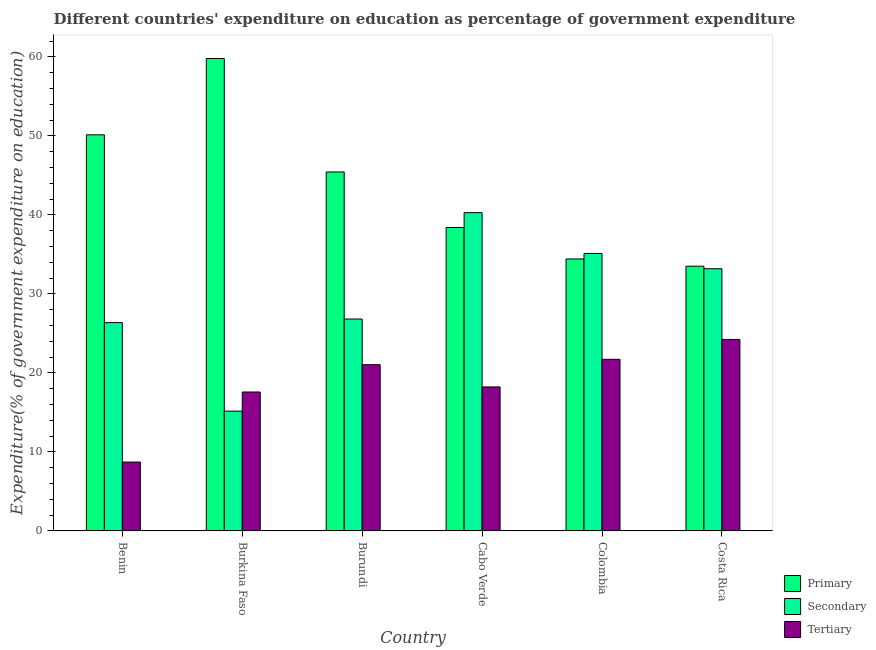How many groups of bars are there?
Keep it short and to the point. 6. Are the number of bars per tick equal to the number of legend labels?
Your answer should be compact. Yes. Are the number of bars on each tick of the X-axis equal?
Ensure brevity in your answer.  Yes. What is the label of the 6th group of bars from the left?
Offer a very short reply. Costa Rica. What is the expenditure on primary education in Burundi?
Your answer should be compact. 45.43. Across all countries, what is the maximum expenditure on primary education?
Offer a terse response. 59.79. Across all countries, what is the minimum expenditure on primary education?
Make the answer very short. 33.5. In which country was the expenditure on secondary education maximum?
Keep it short and to the point. Cabo Verde. In which country was the expenditure on secondary education minimum?
Offer a very short reply. Burkina Faso. What is the total expenditure on tertiary education in the graph?
Your response must be concise. 111.51. What is the difference between the expenditure on tertiary education in Cabo Verde and that in Colombia?
Give a very brief answer. -3.49. What is the difference between the expenditure on tertiary education in Benin and the expenditure on primary education in Cabo Verde?
Keep it short and to the point. -29.68. What is the average expenditure on secondary education per country?
Offer a very short reply. 29.49. What is the difference between the expenditure on secondary education and expenditure on primary education in Colombia?
Provide a short and direct response. 0.69. In how many countries, is the expenditure on primary education greater than 14 %?
Your answer should be very brief. 6. What is the ratio of the expenditure on secondary education in Burundi to that in Costa Rica?
Your response must be concise. 0.81. What is the difference between the highest and the second highest expenditure on tertiary education?
Offer a terse response. 2.52. What is the difference between the highest and the lowest expenditure on secondary education?
Ensure brevity in your answer.  25.12. Is the sum of the expenditure on primary education in Benin and Burundi greater than the maximum expenditure on tertiary education across all countries?
Keep it short and to the point. Yes. What does the 3rd bar from the left in Costa Rica represents?
Provide a short and direct response. Tertiary. What does the 3rd bar from the right in Burkina Faso represents?
Ensure brevity in your answer.  Primary. How many bars are there?
Provide a succinct answer. 18. What is the difference between two consecutive major ticks on the Y-axis?
Your response must be concise. 10. Are the values on the major ticks of Y-axis written in scientific E-notation?
Give a very brief answer. No. Does the graph contain grids?
Offer a terse response. No. Where does the legend appear in the graph?
Give a very brief answer. Bottom right. How many legend labels are there?
Provide a succinct answer. 3. How are the legend labels stacked?
Offer a very short reply. Vertical. What is the title of the graph?
Offer a terse response. Different countries' expenditure on education as percentage of government expenditure. What is the label or title of the Y-axis?
Your answer should be compact. Expenditure(% of government expenditure on education). What is the Expenditure(% of government expenditure on education) of Primary in Benin?
Keep it short and to the point. 50.13. What is the Expenditure(% of government expenditure on education) in Secondary in Benin?
Your response must be concise. 26.36. What is the Expenditure(% of government expenditure on education) in Tertiary in Benin?
Ensure brevity in your answer.  8.72. What is the Expenditure(% of government expenditure on education) in Primary in Burkina Faso?
Provide a short and direct response. 59.79. What is the Expenditure(% of government expenditure on education) of Secondary in Burkina Faso?
Your answer should be compact. 15.16. What is the Expenditure(% of government expenditure on education) of Tertiary in Burkina Faso?
Your answer should be compact. 17.58. What is the Expenditure(% of government expenditure on education) of Primary in Burundi?
Offer a terse response. 45.43. What is the Expenditure(% of government expenditure on education) of Secondary in Burundi?
Provide a short and direct response. 26.82. What is the Expenditure(% of government expenditure on education) of Tertiary in Burundi?
Make the answer very short. 21.04. What is the Expenditure(% of government expenditure on education) in Primary in Cabo Verde?
Your answer should be compact. 38.4. What is the Expenditure(% of government expenditure on education) of Secondary in Cabo Verde?
Keep it short and to the point. 40.28. What is the Expenditure(% of government expenditure on education) in Tertiary in Cabo Verde?
Your response must be concise. 18.23. What is the Expenditure(% of government expenditure on education) in Primary in Colombia?
Your answer should be compact. 34.42. What is the Expenditure(% of government expenditure on education) of Secondary in Colombia?
Ensure brevity in your answer.  35.11. What is the Expenditure(% of government expenditure on education) of Tertiary in Colombia?
Provide a succinct answer. 21.72. What is the Expenditure(% of government expenditure on education) in Primary in Costa Rica?
Ensure brevity in your answer.  33.5. What is the Expenditure(% of government expenditure on education) of Secondary in Costa Rica?
Give a very brief answer. 33.18. What is the Expenditure(% of government expenditure on education) of Tertiary in Costa Rica?
Your response must be concise. 24.23. Across all countries, what is the maximum Expenditure(% of government expenditure on education) in Primary?
Provide a short and direct response. 59.79. Across all countries, what is the maximum Expenditure(% of government expenditure on education) of Secondary?
Ensure brevity in your answer.  40.28. Across all countries, what is the maximum Expenditure(% of government expenditure on education) in Tertiary?
Your response must be concise. 24.23. Across all countries, what is the minimum Expenditure(% of government expenditure on education) in Primary?
Make the answer very short. 33.5. Across all countries, what is the minimum Expenditure(% of government expenditure on education) of Secondary?
Provide a short and direct response. 15.16. Across all countries, what is the minimum Expenditure(% of government expenditure on education) of Tertiary?
Offer a terse response. 8.72. What is the total Expenditure(% of government expenditure on education) in Primary in the graph?
Ensure brevity in your answer.  261.67. What is the total Expenditure(% of government expenditure on education) of Secondary in the graph?
Offer a very short reply. 176.92. What is the total Expenditure(% of government expenditure on education) of Tertiary in the graph?
Offer a terse response. 111.51. What is the difference between the Expenditure(% of government expenditure on education) in Primary in Benin and that in Burkina Faso?
Make the answer very short. -9.66. What is the difference between the Expenditure(% of government expenditure on education) in Secondary in Benin and that in Burkina Faso?
Provide a succinct answer. 11.2. What is the difference between the Expenditure(% of government expenditure on education) of Tertiary in Benin and that in Burkina Faso?
Provide a short and direct response. -8.87. What is the difference between the Expenditure(% of government expenditure on education) in Primary in Benin and that in Burundi?
Keep it short and to the point. 4.7. What is the difference between the Expenditure(% of government expenditure on education) in Secondary in Benin and that in Burundi?
Ensure brevity in your answer.  -0.45. What is the difference between the Expenditure(% of government expenditure on education) in Tertiary in Benin and that in Burundi?
Provide a short and direct response. -12.32. What is the difference between the Expenditure(% of government expenditure on education) of Primary in Benin and that in Cabo Verde?
Provide a short and direct response. 11.73. What is the difference between the Expenditure(% of government expenditure on education) of Secondary in Benin and that in Cabo Verde?
Provide a succinct answer. -13.92. What is the difference between the Expenditure(% of government expenditure on education) of Tertiary in Benin and that in Cabo Verde?
Your answer should be very brief. -9.51. What is the difference between the Expenditure(% of government expenditure on education) in Primary in Benin and that in Colombia?
Provide a short and direct response. 15.71. What is the difference between the Expenditure(% of government expenditure on education) in Secondary in Benin and that in Colombia?
Ensure brevity in your answer.  -8.75. What is the difference between the Expenditure(% of government expenditure on education) in Tertiary in Benin and that in Colombia?
Your answer should be very brief. -13. What is the difference between the Expenditure(% of government expenditure on education) of Primary in Benin and that in Costa Rica?
Provide a short and direct response. 16.63. What is the difference between the Expenditure(% of government expenditure on education) of Secondary in Benin and that in Costa Rica?
Provide a short and direct response. -6.82. What is the difference between the Expenditure(% of government expenditure on education) of Tertiary in Benin and that in Costa Rica?
Keep it short and to the point. -15.52. What is the difference between the Expenditure(% of government expenditure on education) of Primary in Burkina Faso and that in Burundi?
Offer a terse response. 14.36. What is the difference between the Expenditure(% of government expenditure on education) of Secondary in Burkina Faso and that in Burundi?
Give a very brief answer. -11.66. What is the difference between the Expenditure(% of government expenditure on education) in Tertiary in Burkina Faso and that in Burundi?
Your response must be concise. -3.45. What is the difference between the Expenditure(% of government expenditure on education) of Primary in Burkina Faso and that in Cabo Verde?
Your response must be concise. 21.39. What is the difference between the Expenditure(% of government expenditure on education) in Secondary in Burkina Faso and that in Cabo Verde?
Your response must be concise. -25.12. What is the difference between the Expenditure(% of government expenditure on education) in Tertiary in Burkina Faso and that in Cabo Verde?
Ensure brevity in your answer.  -0.64. What is the difference between the Expenditure(% of government expenditure on education) in Primary in Burkina Faso and that in Colombia?
Provide a succinct answer. 25.37. What is the difference between the Expenditure(% of government expenditure on education) in Secondary in Burkina Faso and that in Colombia?
Offer a very short reply. -19.95. What is the difference between the Expenditure(% of government expenditure on education) in Tertiary in Burkina Faso and that in Colombia?
Provide a succinct answer. -4.14. What is the difference between the Expenditure(% of government expenditure on education) in Primary in Burkina Faso and that in Costa Rica?
Keep it short and to the point. 26.29. What is the difference between the Expenditure(% of government expenditure on education) of Secondary in Burkina Faso and that in Costa Rica?
Your response must be concise. -18.02. What is the difference between the Expenditure(% of government expenditure on education) of Tertiary in Burkina Faso and that in Costa Rica?
Give a very brief answer. -6.65. What is the difference between the Expenditure(% of government expenditure on education) of Primary in Burundi and that in Cabo Verde?
Ensure brevity in your answer.  7.03. What is the difference between the Expenditure(% of government expenditure on education) in Secondary in Burundi and that in Cabo Verde?
Offer a terse response. -13.46. What is the difference between the Expenditure(% of government expenditure on education) in Tertiary in Burundi and that in Cabo Verde?
Offer a very short reply. 2.81. What is the difference between the Expenditure(% of government expenditure on education) of Primary in Burundi and that in Colombia?
Give a very brief answer. 11.01. What is the difference between the Expenditure(% of government expenditure on education) of Secondary in Burundi and that in Colombia?
Your answer should be compact. -8.3. What is the difference between the Expenditure(% of government expenditure on education) of Tertiary in Burundi and that in Colombia?
Provide a succinct answer. -0.68. What is the difference between the Expenditure(% of government expenditure on education) of Primary in Burundi and that in Costa Rica?
Provide a succinct answer. 11.93. What is the difference between the Expenditure(% of government expenditure on education) in Secondary in Burundi and that in Costa Rica?
Your answer should be compact. -6.37. What is the difference between the Expenditure(% of government expenditure on education) of Tertiary in Burundi and that in Costa Rica?
Offer a very short reply. -3.2. What is the difference between the Expenditure(% of government expenditure on education) in Primary in Cabo Verde and that in Colombia?
Give a very brief answer. 3.98. What is the difference between the Expenditure(% of government expenditure on education) of Secondary in Cabo Verde and that in Colombia?
Ensure brevity in your answer.  5.17. What is the difference between the Expenditure(% of government expenditure on education) in Tertiary in Cabo Verde and that in Colombia?
Your answer should be very brief. -3.49. What is the difference between the Expenditure(% of government expenditure on education) of Primary in Cabo Verde and that in Costa Rica?
Keep it short and to the point. 4.9. What is the difference between the Expenditure(% of government expenditure on education) of Secondary in Cabo Verde and that in Costa Rica?
Provide a succinct answer. 7.1. What is the difference between the Expenditure(% of government expenditure on education) in Tertiary in Cabo Verde and that in Costa Rica?
Your answer should be very brief. -6.01. What is the difference between the Expenditure(% of government expenditure on education) in Primary in Colombia and that in Costa Rica?
Provide a short and direct response. 0.92. What is the difference between the Expenditure(% of government expenditure on education) of Secondary in Colombia and that in Costa Rica?
Provide a succinct answer. 1.93. What is the difference between the Expenditure(% of government expenditure on education) of Tertiary in Colombia and that in Costa Rica?
Offer a terse response. -2.52. What is the difference between the Expenditure(% of government expenditure on education) in Primary in Benin and the Expenditure(% of government expenditure on education) in Secondary in Burkina Faso?
Offer a terse response. 34.97. What is the difference between the Expenditure(% of government expenditure on education) of Primary in Benin and the Expenditure(% of government expenditure on education) of Tertiary in Burkina Faso?
Keep it short and to the point. 32.55. What is the difference between the Expenditure(% of government expenditure on education) in Secondary in Benin and the Expenditure(% of government expenditure on education) in Tertiary in Burkina Faso?
Your answer should be very brief. 8.78. What is the difference between the Expenditure(% of government expenditure on education) of Primary in Benin and the Expenditure(% of government expenditure on education) of Secondary in Burundi?
Your answer should be very brief. 23.31. What is the difference between the Expenditure(% of government expenditure on education) in Primary in Benin and the Expenditure(% of government expenditure on education) in Tertiary in Burundi?
Your answer should be very brief. 29.09. What is the difference between the Expenditure(% of government expenditure on education) of Secondary in Benin and the Expenditure(% of government expenditure on education) of Tertiary in Burundi?
Ensure brevity in your answer.  5.33. What is the difference between the Expenditure(% of government expenditure on education) in Primary in Benin and the Expenditure(% of government expenditure on education) in Secondary in Cabo Verde?
Your answer should be compact. 9.85. What is the difference between the Expenditure(% of government expenditure on education) of Primary in Benin and the Expenditure(% of government expenditure on education) of Tertiary in Cabo Verde?
Ensure brevity in your answer.  31.9. What is the difference between the Expenditure(% of government expenditure on education) in Secondary in Benin and the Expenditure(% of government expenditure on education) in Tertiary in Cabo Verde?
Your response must be concise. 8.14. What is the difference between the Expenditure(% of government expenditure on education) in Primary in Benin and the Expenditure(% of government expenditure on education) in Secondary in Colombia?
Offer a terse response. 15.01. What is the difference between the Expenditure(% of government expenditure on education) of Primary in Benin and the Expenditure(% of government expenditure on education) of Tertiary in Colombia?
Your response must be concise. 28.41. What is the difference between the Expenditure(% of government expenditure on education) in Secondary in Benin and the Expenditure(% of government expenditure on education) in Tertiary in Colombia?
Your answer should be compact. 4.65. What is the difference between the Expenditure(% of government expenditure on education) of Primary in Benin and the Expenditure(% of government expenditure on education) of Secondary in Costa Rica?
Give a very brief answer. 16.94. What is the difference between the Expenditure(% of government expenditure on education) of Primary in Benin and the Expenditure(% of government expenditure on education) of Tertiary in Costa Rica?
Keep it short and to the point. 25.89. What is the difference between the Expenditure(% of government expenditure on education) of Secondary in Benin and the Expenditure(% of government expenditure on education) of Tertiary in Costa Rica?
Your answer should be very brief. 2.13. What is the difference between the Expenditure(% of government expenditure on education) in Primary in Burkina Faso and the Expenditure(% of government expenditure on education) in Secondary in Burundi?
Offer a terse response. 32.97. What is the difference between the Expenditure(% of government expenditure on education) of Primary in Burkina Faso and the Expenditure(% of government expenditure on education) of Tertiary in Burundi?
Your response must be concise. 38.75. What is the difference between the Expenditure(% of government expenditure on education) in Secondary in Burkina Faso and the Expenditure(% of government expenditure on education) in Tertiary in Burundi?
Offer a very short reply. -5.87. What is the difference between the Expenditure(% of government expenditure on education) of Primary in Burkina Faso and the Expenditure(% of government expenditure on education) of Secondary in Cabo Verde?
Ensure brevity in your answer.  19.51. What is the difference between the Expenditure(% of government expenditure on education) in Primary in Burkina Faso and the Expenditure(% of government expenditure on education) in Tertiary in Cabo Verde?
Provide a short and direct response. 41.56. What is the difference between the Expenditure(% of government expenditure on education) of Secondary in Burkina Faso and the Expenditure(% of government expenditure on education) of Tertiary in Cabo Verde?
Your answer should be compact. -3.06. What is the difference between the Expenditure(% of government expenditure on education) of Primary in Burkina Faso and the Expenditure(% of government expenditure on education) of Secondary in Colombia?
Ensure brevity in your answer.  24.67. What is the difference between the Expenditure(% of government expenditure on education) of Primary in Burkina Faso and the Expenditure(% of government expenditure on education) of Tertiary in Colombia?
Your answer should be compact. 38.07. What is the difference between the Expenditure(% of government expenditure on education) of Secondary in Burkina Faso and the Expenditure(% of government expenditure on education) of Tertiary in Colombia?
Your answer should be compact. -6.56. What is the difference between the Expenditure(% of government expenditure on education) of Primary in Burkina Faso and the Expenditure(% of government expenditure on education) of Secondary in Costa Rica?
Make the answer very short. 26.6. What is the difference between the Expenditure(% of government expenditure on education) of Primary in Burkina Faso and the Expenditure(% of government expenditure on education) of Tertiary in Costa Rica?
Provide a short and direct response. 35.55. What is the difference between the Expenditure(% of government expenditure on education) of Secondary in Burkina Faso and the Expenditure(% of government expenditure on education) of Tertiary in Costa Rica?
Ensure brevity in your answer.  -9.07. What is the difference between the Expenditure(% of government expenditure on education) in Primary in Burundi and the Expenditure(% of government expenditure on education) in Secondary in Cabo Verde?
Provide a short and direct response. 5.15. What is the difference between the Expenditure(% of government expenditure on education) in Primary in Burundi and the Expenditure(% of government expenditure on education) in Tertiary in Cabo Verde?
Your answer should be very brief. 27.2. What is the difference between the Expenditure(% of government expenditure on education) in Secondary in Burundi and the Expenditure(% of government expenditure on education) in Tertiary in Cabo Verde?
Keep it short and to the point. 8.59. What is the difference between the Expenditure(% of government expenditure on education) of Primary in Burundi and the Expenditure(% of government expenditure on education) of Secondary in Colombia?
Offer a very short reply. 10.32. What is the difference between the Expenditure(% of government expenditure on education) of Primary in Burundi and the Expenditure(% of government expenditure on education) of Tertiary in Colombia?
Keep it short and to the point. 23.71. What is the difference between the Expenditure(% of government expenditure on education) in Secondary in Burundi and the Expenditure(% of government expenditure on education) in Tertiary in Colombia?
Your answer should be compact. 5.1. What is the difference between the Expenditure(% of government expenditure on education) of Primary in Burundi and the Expenditure(% of government expenditure on education) of Secondary in Costa Rica?
Your response must be concise. 12.25. What is the difference between the Expenditure(% of government expenditure on education) of Primary in Burundi and the Expenditure(% of government expenditure on education) of Tertiary in Costa Rica?
Keep it short and to the point. 21.2. What is the difference between the Expenditure(% of government expenditure on education) in Secondary in Burundi and the Expenditure(% of government expenditure on education) in Tertiary in Costa Rica?
Keep it short and to the point. 2.58. What is the difference between the Expenditure(% of government expenditure on education) of Primary in Cabo Verde and the Expenditure(% of government expenditure on education) of Secondary in Colombia?
Offer a very short reply. 3.28. What is the difference between the Expenditure(% of government expenditure on education) of Primary in Cabo Verde and the Expenditure(% of government expenditure on education) of Tertiary in Colombia?
Your answer should be very brief. 16.68. What is the difference between the Expenditure(% of government expenditure on education) in Secondary in Cabo Verde and the Expenditure(% of government expenditure on education) in Tertiary in Colombia?
Offer a terse response. 18.56. What is the difference between the Expenditure(% of government expenditure on education) in Primary in Cabo Verde and the Expenditure(% of government expenditure on education) in Secondary in Costa Rica?
Make the answer very short. 5.21. What is the difference between the Expenditure(% of government expenditure on education) of Primary in Cabo Verde and the Expenditure(% of government expenditure on education) of Tertiary in Costa Rica?
Give a very brief answer. 14.17. What is the difference between the Expenditure(% of government expenditure on education) in Secondary in Cabo Verde and the Expenditure(% of government expenditure on education) in Tertiary in Costa Rica?
Make the answer very short. 16.05. What is the difference between the Expenditure(% of government expenditure on education) of Primary in Colombia and the Expenditure(% of government expenditure on education) of Secondary in Costa Rica?
Make the answer very short. 1.24. What is the difference between the Expenditure(% of government expenditure on education) in Primary in Colombia and the Expenditure(% of government expenditure on education) in Tertiary in Costa Rica?
Your response must be concise. 10.19. What is the difference between the Expenditure(% of government expenditure on education) in Secondary in Colombia and the Expenditure(% of government expenditure on education) in Tertiary in Costa Rica?
Offer a terse response. 10.88. What is the average Expenditure(% of government expenditure on education) in Primary per country?
Offer a very short reply. 43.61. What is the average Expenditure(% of government expenditure on education) of Secondary per country?
Offer a terse response. 29.49. What is the average Expenditure(% of government expenditure on education) of Tertiary per country?
Give a very brief answer. 18.59. What is the difference between the Expenditure(% of government expenditure on education) in Primary and Expenditure(% of government expenditure on education) in Secondary in Benin?
Keep it short and to the point. 23.76. What is the difference between the Expenditure(% of government expenditure on education) in Primary and Expenditure(% of government expenditure on education) in Tertiary in Benin?
Offer a very short reply. 41.41. What is the difference between the Expenditure(% of government expenditure on education) in Secondary and Expenditure(% of government expenditure on education) in Tertiary in Benin?
Provide a short and direct response. 17.65. What is the difference between the Expenditure(% of government expenditure on education) in Primary and Expenditure(% of government expenditure on education) in Secondary in Burkina Faso?
Your response must be concise. 44.63. What is the difference between the Expenditure(% of government expenditure on education) of Primary and Expenditure(% of government expenditure on education) of Tertiary in Burkina Faso?
Offer a terse response. 42.2. What is the difference between the Expenditure(% of government expenditure on education) of Secondary and Expenditure(% of government expenditure on education) of Tertiary in Burkina Faso?
Provide a short and direct response. -2.42. What is the difference between the Expenditure(% of government expenditure on education) in Primary and Expenditure(% of government expenditure on education) in Secondary in Burundi?
Your answer should be very brief. 18.61. What is the difference between the Expenditure(% of government expenditure on education) of Primary and Expenditure(% of government expenditure on education) of Tertiary in Burundi?
Offer a terse response. 24.39. What is the difference between the Expenditure(% of government expenditure on education) of Secondary and Expenditure(% of government expenditure on education) of Tertiary in Burundi?
Offer a very short reply. 5.78. What is the difference between the Expenditure(% of government expenditure on education) in Primary and Expenditure(% of government expenditure on education) in Secondary in Cabo Verde?
Your answer should be compact. -1.88. What is the difference between the Expenditure(% of government expenditure on education) in Primary and Expenditure(% of government expenditure on education) in Tertiary in Cabo Verde?
Offer a very short reply. 20.17. What is the difference between the Expenditure(% of government expenditure on education) in Secondary and Expenditure(% of government expenditure on education) in Tertiary in Cabo Verde?
Your response must be concise. 22.06. What is the difference between the Expenditure(% of government expenditure on education) of Primary and Expenditure(% of government expenditure on education) of Secondary in Colombia?
Provide a succinct answer. -0.69. What is the difference between the Expenditure(% of government expenditure on education) of Primary and Expenditure(% of government expenditure on education) of Tertiary in Colombia?
Keep it short and to the point. 12.7. What is the difference between the Expenditure(% of government expenditure on education) of Secondary and Expenditure(% of government expenditure on education) of Tertiary in Colombia?
Your answer should be compact. 13.4. What is the difference between the Expenditure(% of government expenditure on education) of Primary and Expenditure(% of government expenditure on education) of Secondary in Costa Rica?
Offer a very short reply. 0.32. What is the difference between the Expenditure(% of government expenditure on education) in Primary and Expenditure(% of government expenditure on education) in Tertiary in Costa Rica?
Keep it short and to the point. 9.27. What is the difference between the Expenditure(% of government expenditure on education) in Secondary and Expenditure(% of government expenditure on education) in Tertiary in Costa Rica?
Offer a terse response. 8.95. What is the ratio of the Expenditure(% of government expenditure on education) of Primary in Benin to that in Burkina Faso?
Provide a succinct answer. 0.84. What is the ratio of the Expenditure(% of government expenditure on education) of Secondary in Benin to that in Burkina Faso?
Your answer should be compact. 1.74. What is the ratio of the Expenditure(% of government expenditure on education) in Tertiary in Benin to that in Burkina Faso?
Make the answer very short. 0.5. What is the ratio of the Expenditure(% of government expenditure on education) in Primary in Benin to that in Burundi?
Ensure brevity in your answer.  1.1. What is the ratio of the Expenditure(% of government expenditure on education) in Secondary in Benin to that in Burundi?
Offer a terse response. 0.98. What is the ratio of the Expenditure(% of government expenditure on education) of Tertiary in Benin to that in Burundi?
Give a very brief answer. 0.41. What is the ratio of the Expenditure(% of government expenditure on education) in Primary in Benin to that in Cabo Verde?
Make the answer very short. 1.31. What is the ratio of the Expenditure(% of government expenditure on education) in Secondary in Benin to that in Cabo Verde?
Keep it short and to the point. 0.65. What is the ratio of the Expenditure(% of government expenditure on education) of Tertiary in Benin to that in Cabo Verde?
Your response must be concise. 0.48. What is the ratio of the Expenditure(% of government expenditure on education) in Primary in Benin to that in Colombia?
Make the answer very short. 1.46. What is the ratio of the Expenditure(% of government expenditure on education) in Secondary in Benin to that in Colombia?
Provide a short and direct response. 0.75. What is the ratio of the Expenditure(% of government expenditure on education) of Tertiary in Benin to that in Colombia?
Your response must be concise. 0.4. What is the ratio of the Expenditure(% of government expenditure on education) in Primary in Benin to that in Costa Rica?
Provide a short and direct response. 1.5. What is the ratio of the Expenditure(% of government expenditure on education) in Secondary in Benin to that in Costa Rica?
Give a very brief answer. 0.79. What is the ratio of the Expenditure(% of government expenditure on education) in Tertiary in Benin to that in Costa Rica?
Offer a terse response. 0.36. What is the ratio of the Expenditure(% of government expenditure on education) in Primary in Burkina Faso to that in Burundi?
Keep it short and to the point. 1.32. What is the ratio of the Expenditure(% of government expenditure on education) in Secondary in Burkina Faso to that in Burundi?
Provide a succinct answer. 0.57. What is the ratio of the Expenditure(% of government expenditure on education) in Tertiary in Burkina Faso to that in Burundi?
Offer a very short reply. 0.84. What is the ratio of the Expenditure(% of government expenditure on education) of Primary in Burkina Faso to that in Cabo Verde?
Offer a very short reply. 1.56. What is the ratio of the Expenditure(% of government expenditure on education) in Secondary in Burkina Faso to that in Cabo Verde?
Offer a terse response. 0.38. What is the ratio of the Expenditure(% of government expenditure on education) in Tertiary in Burkina Faso to that in Cabo Verde?
Your answer should be compact. 0.96. What is the ratio of the Expenditure(% of government expenditure on education) of Primary in Burkina Faso to that in Colombia?
Keep it short and to the point. 1.74. What is the ratio of the Expenditure(% of government expenditure on education) in Secondary in Burkina Faso to that in Colombia?
Ensure brevity in your answer.  0.43. What is the ratio of the Expenditure(% of government expenditure on education) in Tertiary in Burkina Faso to that in Colombia?
Provide a succinct answer. 0.81. What is the ratio of the Expenditure(% of government expenditure on education) of Primary in Burkina Faso to that in Costa Rica?
Provide a short and direct response. 1.78. What is the ratio of the Expenditure(% of government expenditure on education) of Secondary in Burkina Faso to that in Costa Rica?
Keep it short and to the point. 0.46. What is the ratio of the Expenditure(% of government expenditure on education) of Tertiary in Burkina Faso to that in Costa Rica?
Provide a succinct answer. 0.73. What is the ratio of the Expenditure(% of government expenditure on education) of Primary in Burundi to that in Cabo Verde?
Offer a terse response. 1.18. What is the ratio of the Expenditure(% of government expenditure on education) in Secondary in Burundi to that in Cabo Verde?
Your response must be concise. 0.67. What is the ratio of the Expenditure(% of government expenditure on education) of Tertiary in Burundi to that in Cabo Verde?
Provide a short and direct response. 1.15. What is the ratio of the Expenditure(% of government expenditure on education) in Primary in Burundi to that in Colombia?
Your response must be concise. 1.32. What is the ratio of the Expenditure(% of government expenditure on education) in Secondary in Burundi to that in Colombia?
Give a very brief answer. 0.76. What is the ratio of the Expenditure(% of government expenditure on education) of Tertiary in Burundi to that in Colombia?
Offer a terse response. 0.97. What is the ratio of the Expenditure(% of government expenditure on education) in Primary in Burundi to that in Costa Rica?
Your response must be concise. 1.36. What is the ratio of the Expenditure(% of government expenditure on education) of Secondary in Burundi to that in Costa Rica?
Give a very brief answer. 0.81. What is the ratio of the Expenditure(% of government expenditure on education) of Tertiary in Burundi to that in Costa Rica?
Make the answer very short. 0.87. What is the ratio of the Expenditure(% of government expenditure on education) of Primary in Cabo Verde to that in Colombia?
Your answer should be very brief. 1.12. What is the ratio of the Expenditure(% of government expenditure on education) of Secondary in Cabo Verde to that in Colombia?
Ensure brevity in your answer.  1.15. What is the ratio of the Expenditure(% of government expenditure on education) of Tertiary in Cabo Verde to that in Colombia?
Offer a terse response. 0.84. What is the ratio of the Expenditure(% of government expenditure on education) of Primary in Cabo Verde to that in Costa Rica?
Your answer should be compact. 1.15. What is the ratio of the Expenditure(% of government expenditure on education) in Secondary in Cabo Verde to that in Costa Rica?
Keep it short and to the point. 1.21. What is the ratio of the Expenditure(% of government expenditure on education) in Tertiary in Cabo Verde to that in Costa Rica?
Give a very brief answer. 0.75. What is the ratio of the Expenditure(% of government expenditure on education) of Primary in Colombia to that in Costa Rica?
Your answer should be compact. 1.03. What is the ratio of the Expenditure(% of government expenditure on education) in Secondary in Colombia to that in Costa Rica?
Ensure brevity in your answer.  1.06. What is the ratio of the Expenditure(% of government expenditure on education) of Tertiary in Colombia to that in Costa Rica?
Offer a very short reply. 0.9. What is the difference between the highest and the second highest Expenditure(% of government expenditure on education) in Primary?
Provide a short and direct response. 9.66. What is the difference between the highest and the second highest Expenditure(% of government expenditure on education) of Secondary?
Make the answer very short. 5.17. What is the difference between the highest and the second highest Expenditure(% of government expenditure on education) in Tertiary?
Provide a short and direct response. 2.52. What is the difference between the highest and the lowest Expenditure(% of government expenditure on education) of Primary?
Your answer should be very brief. 26.29. What is the difference between the highest and the lowest Expenditure(% of government expenditure on education) in Secondary?
Offer a very short reply. 25.12. What is the difference between the highest and the lowest Expenditure(% of government expenditure on education) in Tertiary?
Give a very brief answer. 15.52. 